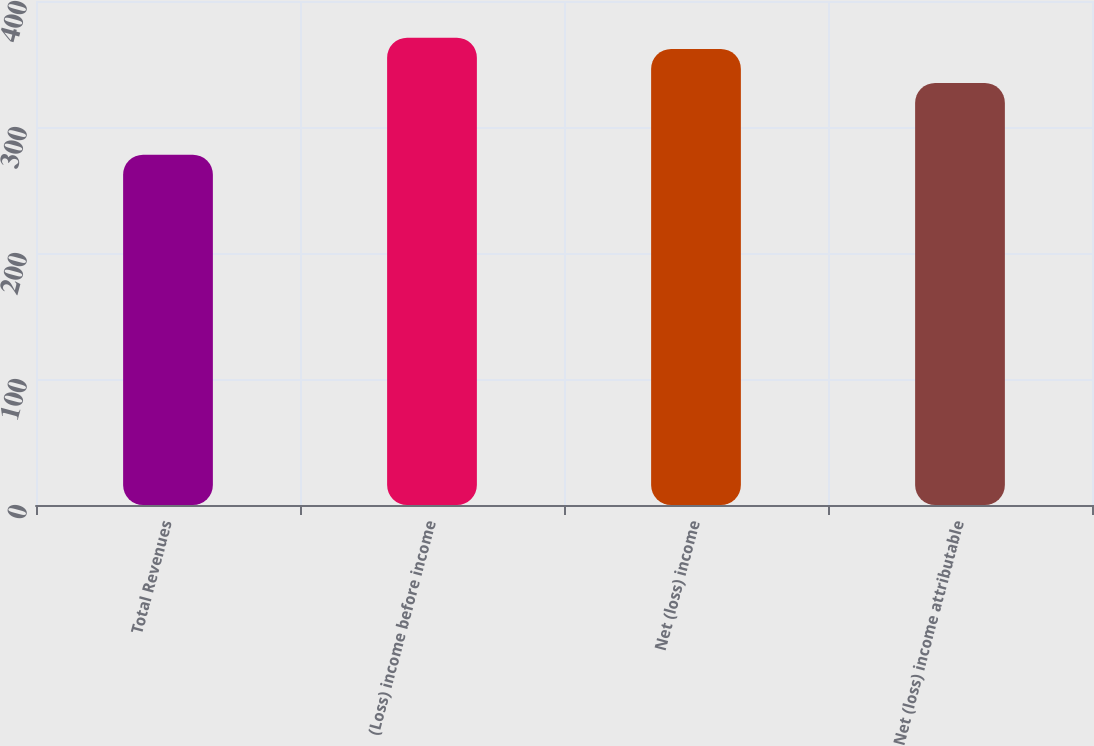<chart> <loc_0><loc_0><loc_500><loc_500><bar_chart><fcel>Total Revenues<fcel>(Loss) income before income<fcel>Net (loss) income<fcel>Net (loss) income attributable<nl><fcel>278<fcel>370.9<fcel>362<fcel>335<nl></chart> 